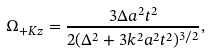Convert formula to latex. <formula><loc_0><loc_0><loc_500><loc_500>\Omega _ { + K z } = \frac { 3 \Delta a ^ { 2 } t ^ { 2 } } { 2 ( \Delta ^ { 2 } + 3 k ^ { 2 } a ^ { 2 } t ^ { 2 } ) ^ { 3 / 2 } } ,</formula> 